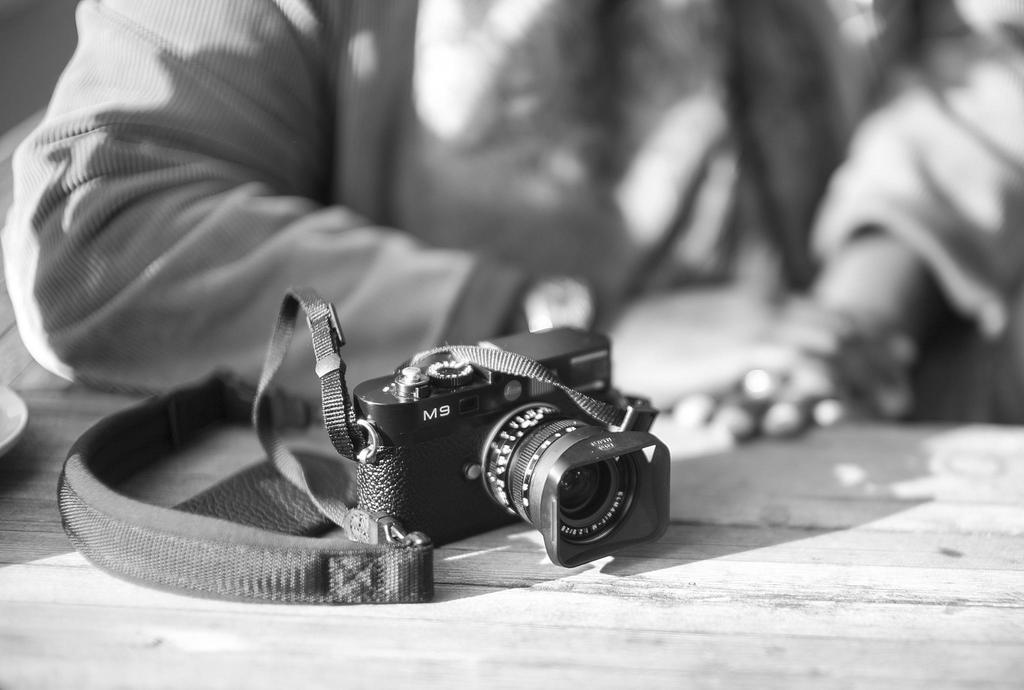<image>
Render a clear and concise summary of the photo. A camera has the label M9 on the front of it. 